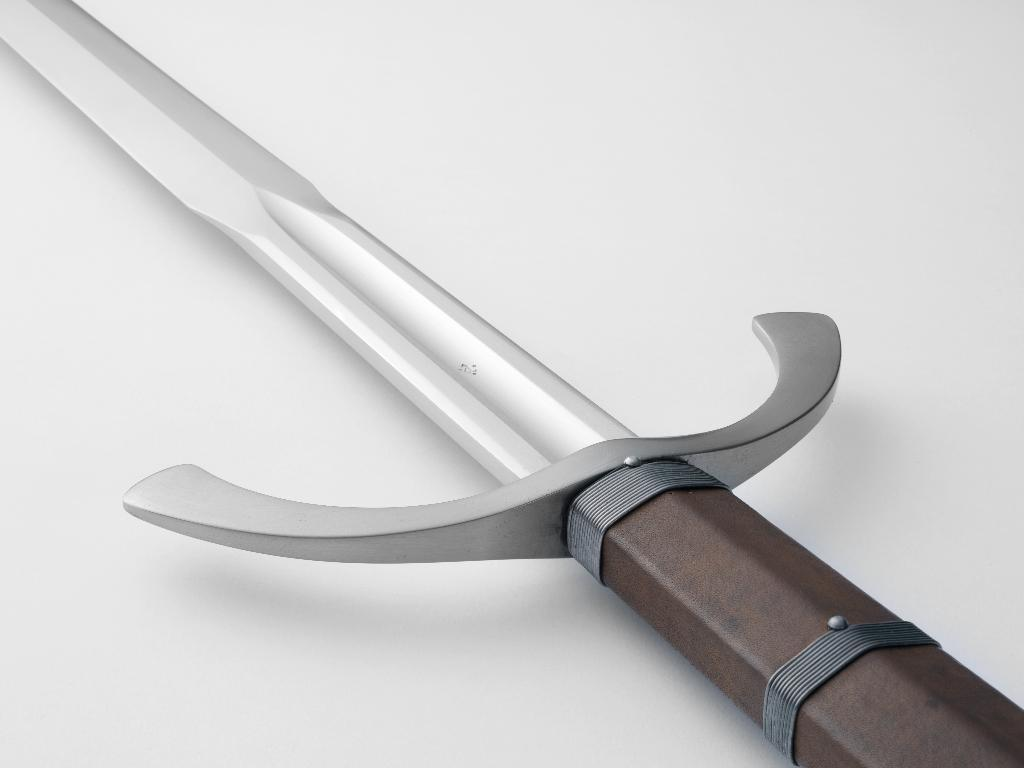What object is the main focus of the image? There is a sword in the image. What is the color of the surface on which the sword is placed? The sword is on a white surface. Where is the robin perched in the image? There is no robin present in the image. What is the pail used for in the image? There is no pail present in the image. 